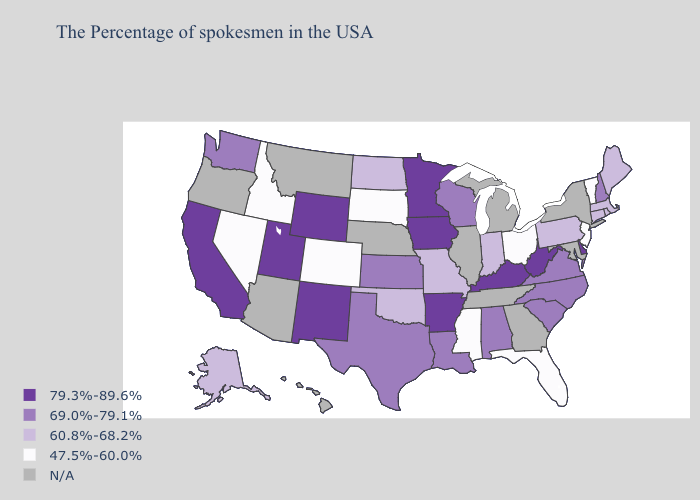What is the value of Wyoming?
Quick response, please. 79.3%-89.6%. What is the highest value in the Northeast ?
Write a very short answer. 69.0%-79.1%. Does Missouri have the highest value in the USA?
Give a very brief answer. No. Name the states that have a value in the range 60.8%-68.2%?
Be succinct. Maine, Massachusetts, Rhode Island, Connecticut, Pennsylvania, Indiana, Missouri, Oklahoma, North Dakota, Alaska. What is the value of Missouri?
Keep it brief. 60.8%-68.2%. Which states hav the highest value in the MidWest?
Concise answer only. Minnesota, Iowa. Name the states that have a value in the range 79.3%-89.6%?
Write a very short answer. Delaware, West Virginia, Kentucky, Arkansas, Minnesota, Iowa, Wyoming, New Mexico, Utah, California. Is the legend a continuous bar?
Concise answer only. No. What is the highest value in states that border Illinois?
Concise answer only. 79.3%-89.6%. Does Alabama have the highest value in the USA?
Concise answer only. No. Name the states that have a value in the range N/A?
Give a very brief answer. New York, Maryland, Georgia, Michigan, Tennessee, Illinois, Nebraska, Montana, Arizona, Oregon, Hawaii. Does New Hampshire have the lowest value in the Northeast?
Concise answer only. No. What is the value of Arizona?
Answer briefly. N/A. What is the value of New Hampshire?
Concise answer only. 69.0%-79.1%. 